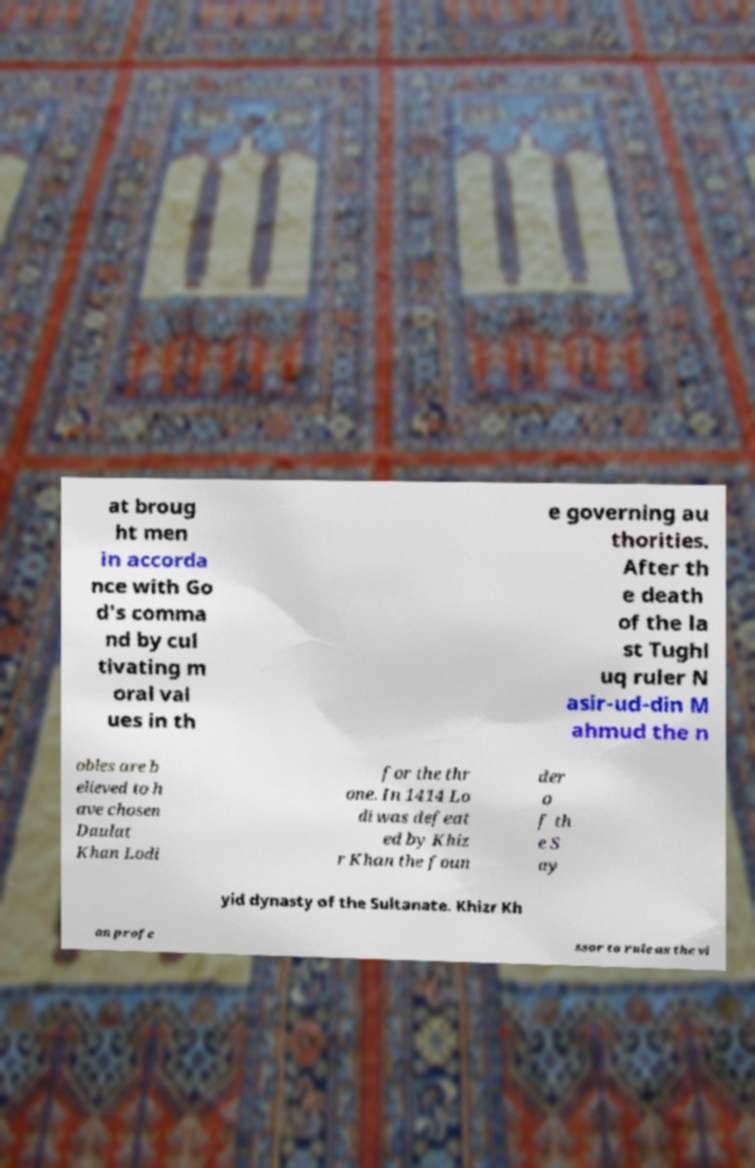There's text embedded in this image that I need extracted. Can you transcribe it verbatim? at broug ht men in accorda nce with Go d's comma nd by cul tivating m oral val ues in th e governing au thorities. After th e death of the la st Tughl uq ruler N asir-ud-din M ahmud the n obles are b elieved to h ave chosen Daulat Khan Lodi for the thr one. In 1414 Lo di was defeat ed by Khiz r Khan the foun der o f th e S ay yid dynasty of the Sultanate. Khizr Kh an profe ssor to rule as the vi 